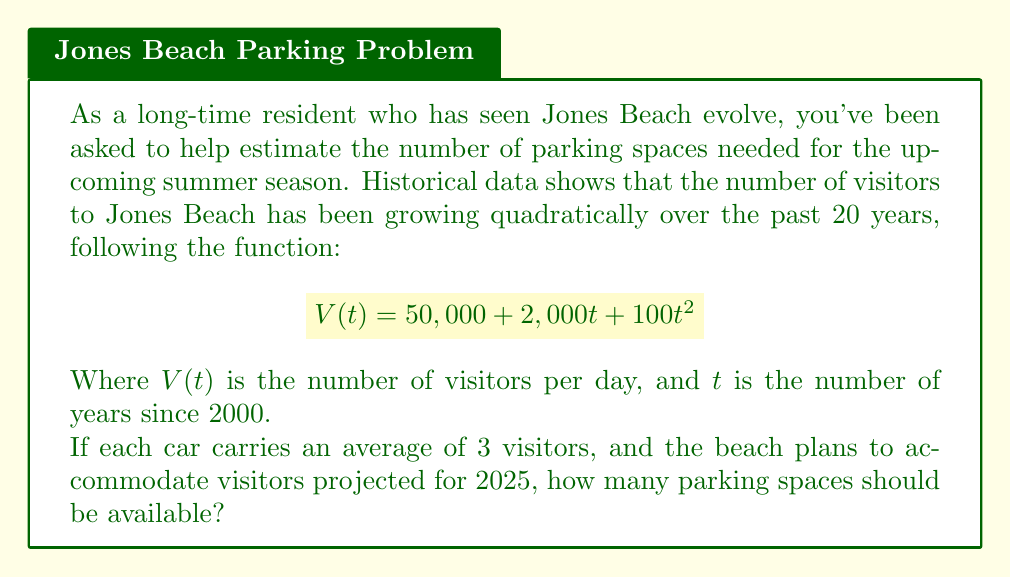Can you solve this math problem? Let's approach this step-by-step:

1) First, we need to determine the value of $t$ for the year 2025:
   2025 - 2000 = 25 years

2) Now, let's calculate the number of visitors expected in 2025 by plugging $t=25$ into our function:

   $$V(25) = 50,000 + 2,000(25) + 100(25)^2$$
   $$V(25) = 50,000 + 50,000 + 62,500$$
   $$V(25) = 162,500$$ visitors per day

3) Since each car carries an average of 3 visitors, we need to divide the total number of visitors by 3 to get the number of cars:

   $$\text{Number of cars} = \frac{162,500}{3} = 54,166.67$$

4) We should round up to ensure we have enough spaces:

   $$\text{Number of parking spaces needed} = 54,167$$

Therefore, Jones Beach should plan for at least 54,167 parking spaces to accommodate the projected number of visitors in 2025.
Answer: 54,167 parking spaces 